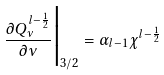<formula> <loc_0><loc_0><loc_500><loc_500>\frac { \partial Q ^ { l - \frac { 1 } { 2 } } _ { \nu } } { \partial \nu } \Big | _ { 3 / 2 } = \alpha _ { l - 1 } \chi ^ { l - \frac { 1 } { 2 } }</formula> 